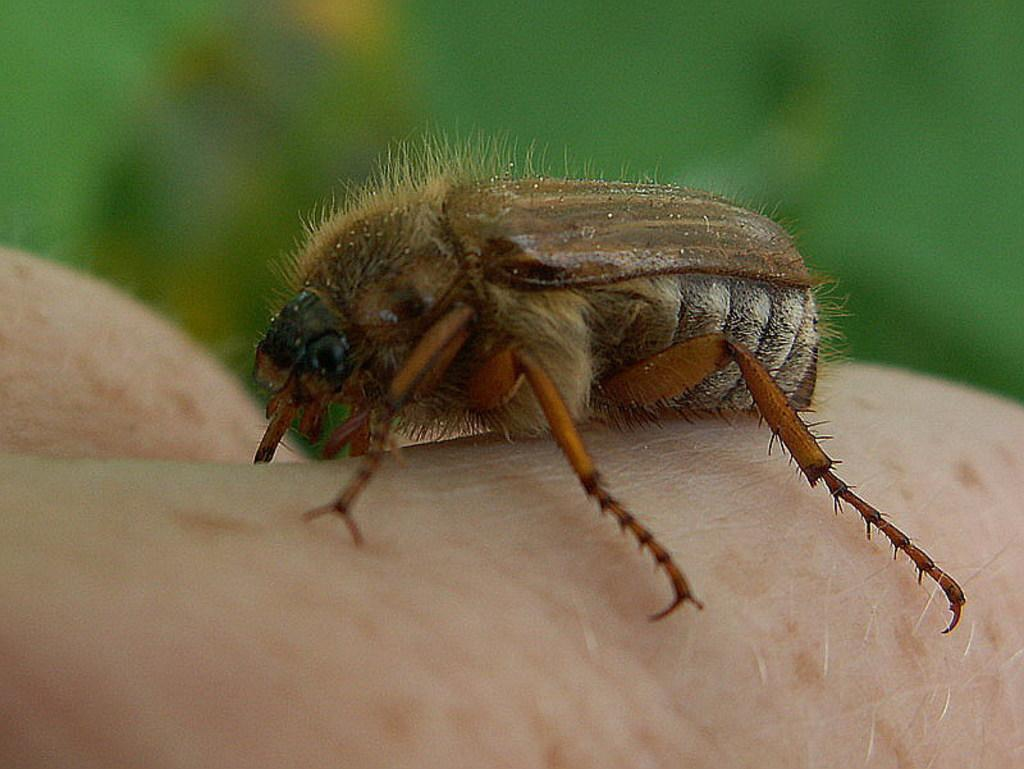What is present on the person's hand in the image? There is an insect on the person's hand in the image. What type of adjustment is being made to the oven in the image? There is no oven present in the image, and therefore no adjustment can be made to it. 